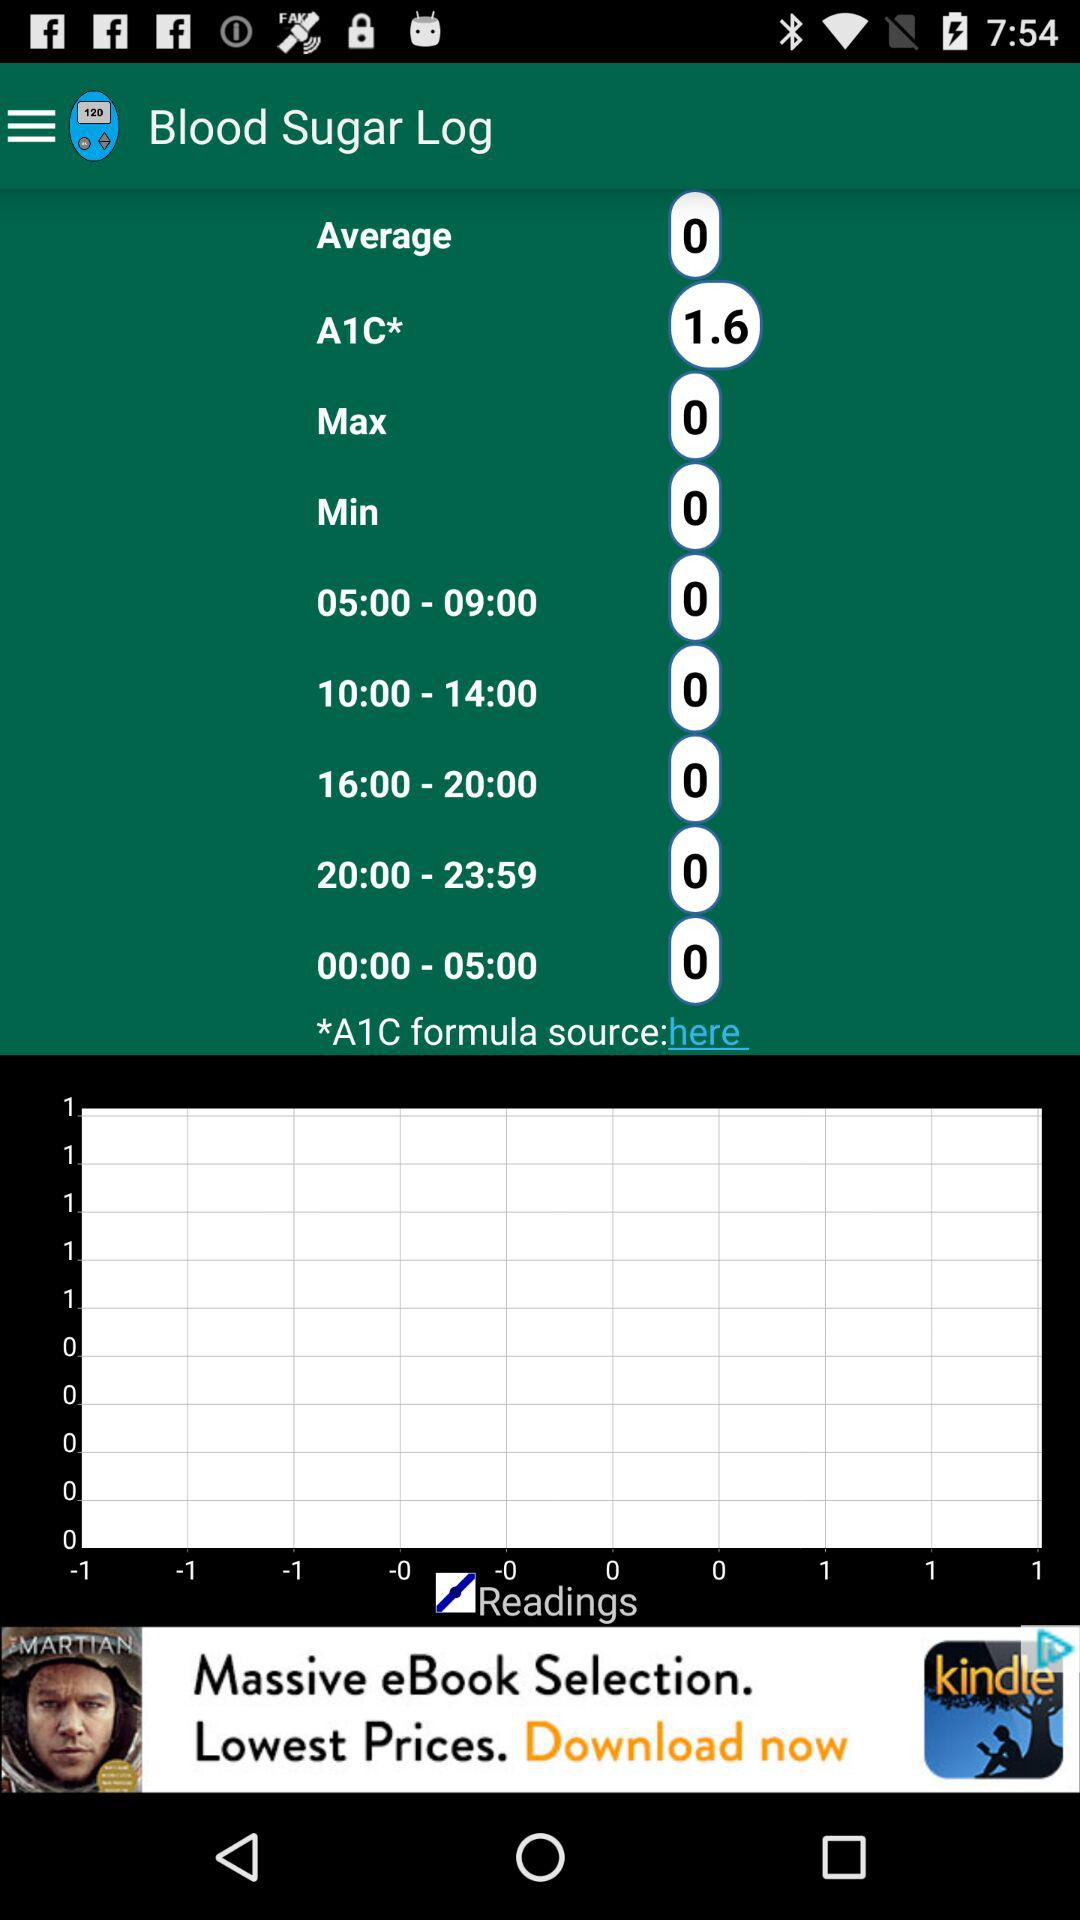What is the maximum blood sugar level? The maximum blood sugar level is 0. 